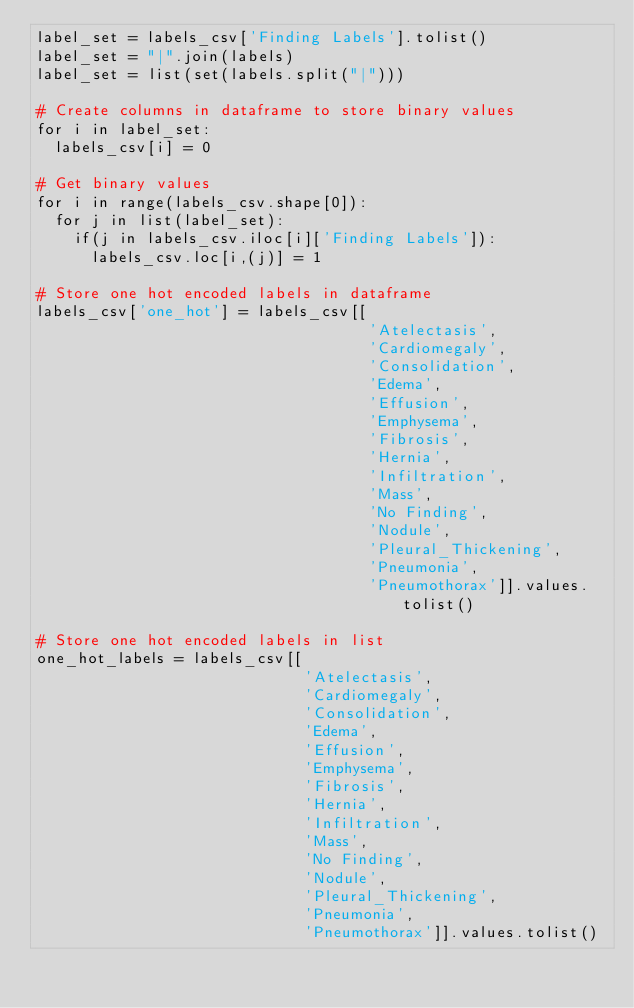Convert code to text. <code><loc_0><loc_0><loc_500><loc_500><_Python_>label_set = labels_csv['Finding Labels'].tolist()
label_set = "|".join(labels)
label_set = list(set(labels.split("|")))

# Create columns in dataframe to store binary values
for i in label_set:
  labels_csv[i] = 0

# Get binary values
for i in range(labels_csv.shape[0]):
  for j in list(label_set):
    if(j in labels_csv.iloc[i]['Finding Labels']):
      labels_csv.loc[i,(j)] = 1

# Store one hot encoded labels in dataframe
labels_csv['one_hot'] = labels_csv[[
                                    'Atelectasis', 
                                    'Cardiomegaly',  
                                    'Consolidation',  
                                    'Edema',  
                                    'Effusion',  
                                    'Emphysema',  
                                    'Fibrosis',  
                                    'Hernia',  
                                    'Infiltration',  
                                    'Mass',  
                                    'No Finding',  
                                    'Nodule',  
                                    'Pleural_Thickening',  
                                    'Pneumonia',  
                                    'Pneumothorax']].values.tolist()

# Store one hot encoded labels in list
one_hot_labels = labels_csv[[
                             'Atelectasis', 
                             'Cardiomegaly',  
                             'Consolidation',  
                             'Edema',  
                             'Effusion',  
                             'Emphysema',  
                             'Fibrosis',  
                             'Hernia',  
                             'Infiltration',  
                             'Mass',  
                             'No Finding',  
                             'Nodule',  
                             'Pleural_Thickening',  
                             'Pneumonia',  
                             'Pneumothorax']].values.tolist()
</code> 